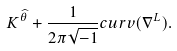<formula> <loc_0><loc_0><loc_500><loc_500>K ^ { \widehat { \theta } } + \frac { 1 } { 2 \pi \sqrt { - 1 } } c u r v ( \nabla ^ { L } ) .</formula> 